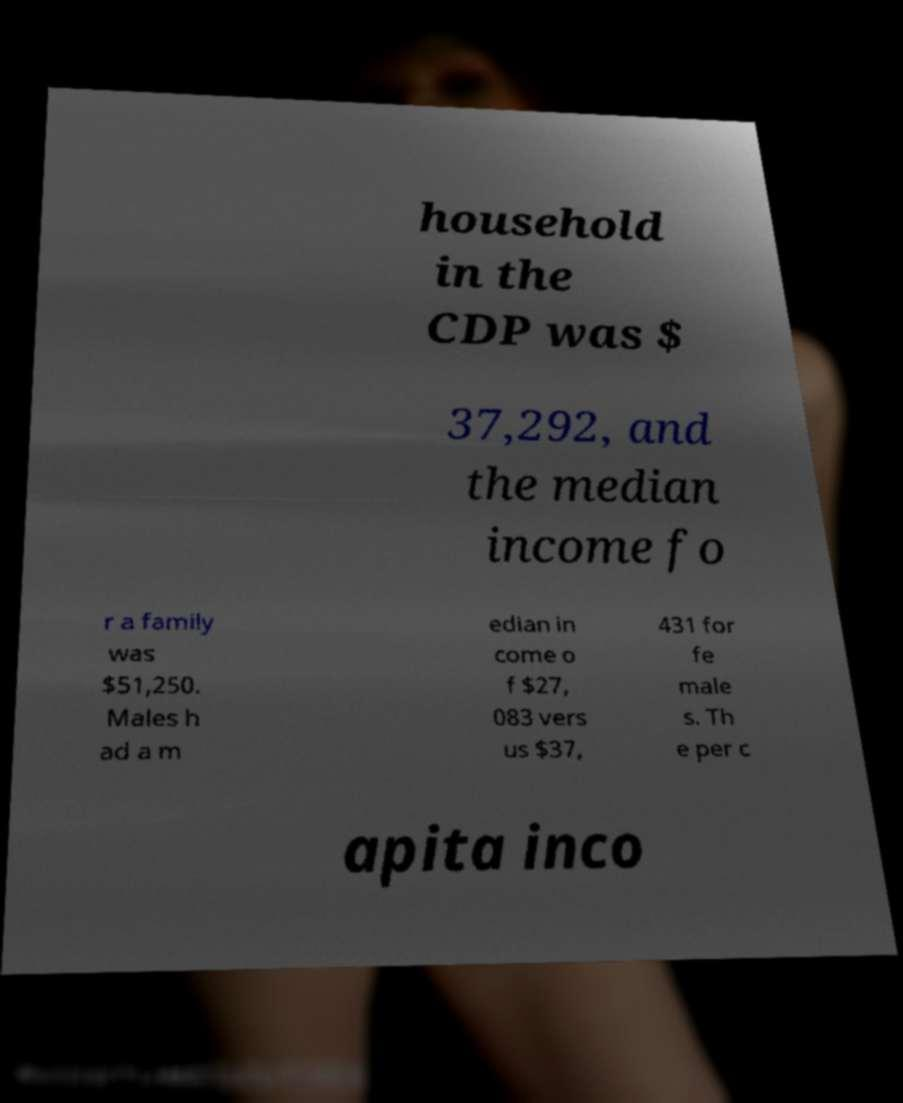For documentation purposes, I need the text within this image transcribed. Could you provide that? household in the CDP was $ 37,292, and the median income fo r a family was $51,250. Males h ad a m edian in come o f $27, 083 vers us $37, 431 for fe male s. Th e per c apita inco 